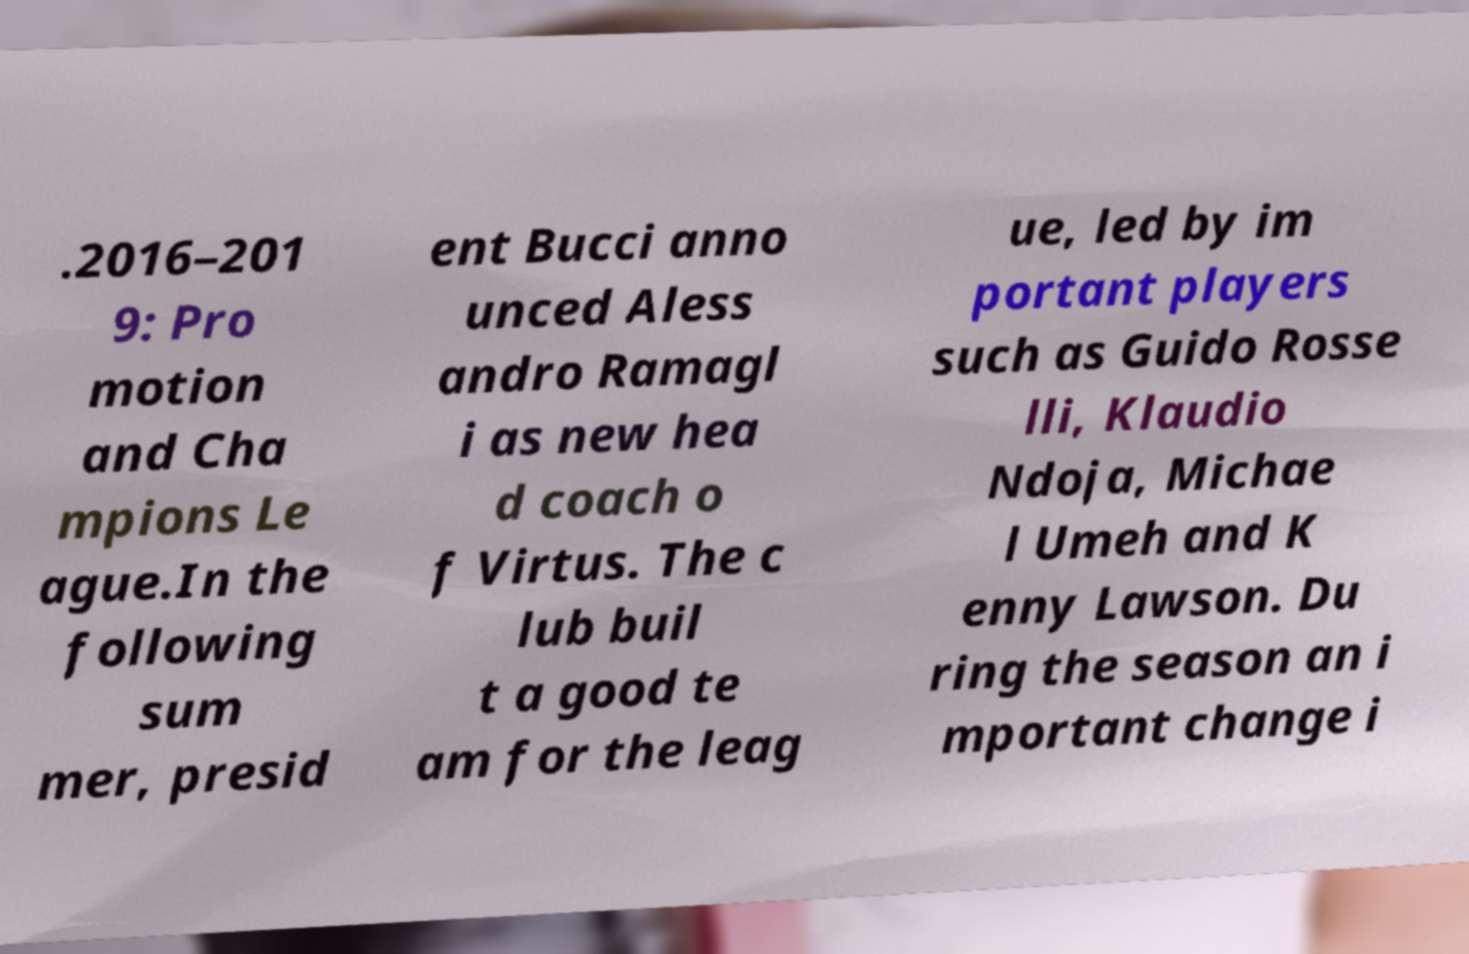I need the written content from this picture converted into text. Can you do that? .2016–201 9: Pro motion and Cha mpions Le ague.In the following sum mer, presid ent Bucci anno unced Aless andro Ramagl i as new hea d coach o f Virtus. The c lub buil t a good te am for the leag ue, led by im portant players such as Guido Rosse lli, Klaudio Ndoja, Michae l Umeh and K enny Lawson. Du ring the season an i mportant change i 